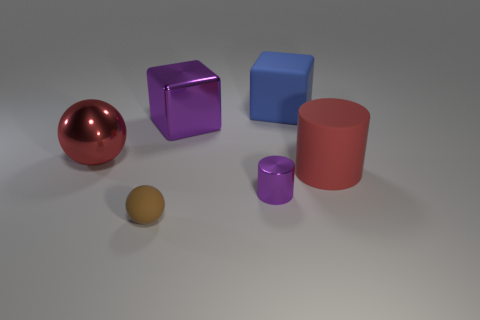Is there a tiny cylinder to the left of the big rubber thing that is behind the red object on the right side of the brown matte thing? yes 